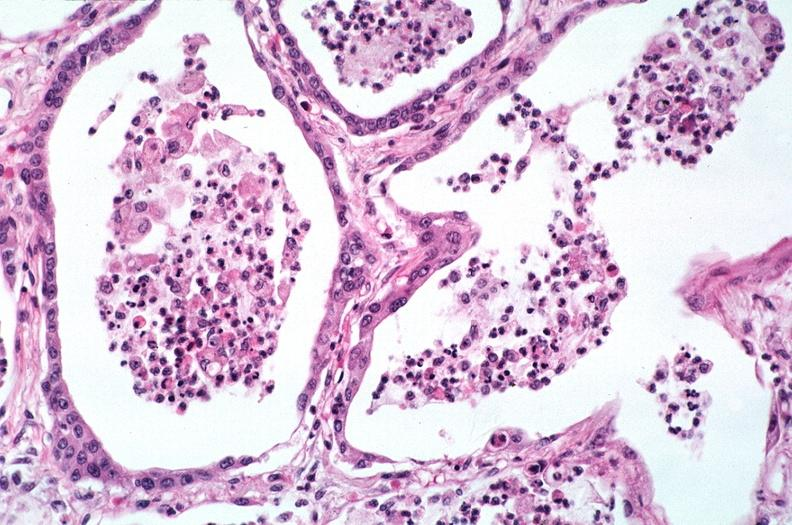what does this image show?
Answer the question using a single word or phrase. Lung 